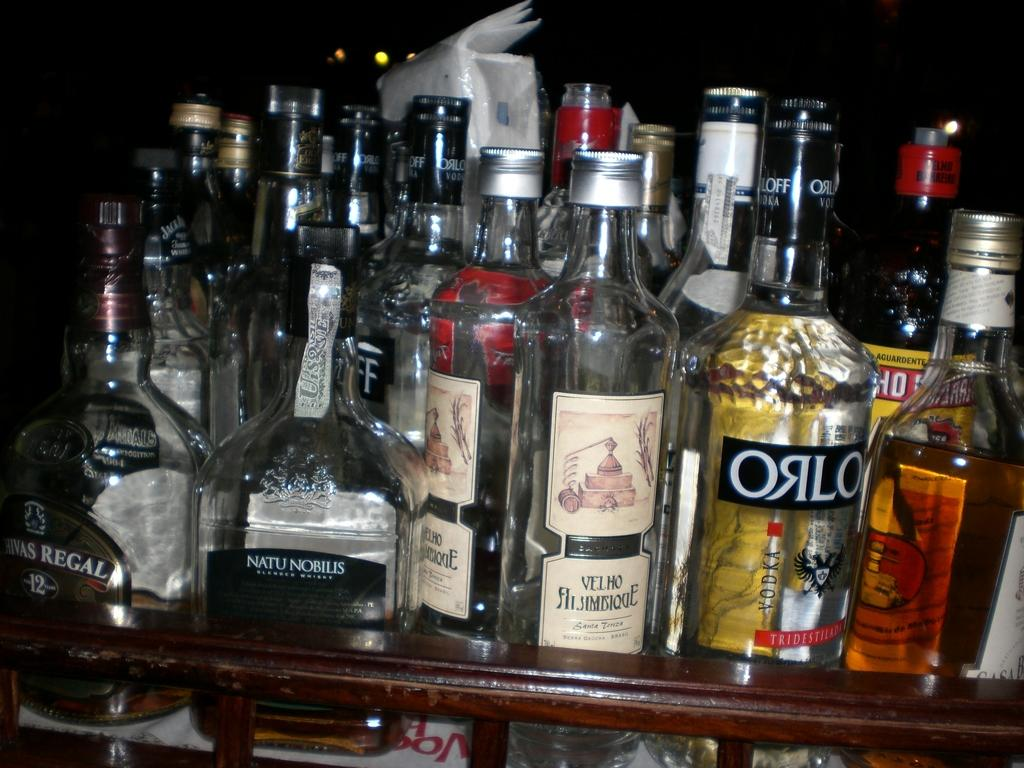<image>
Create a compact narrative representing the image presented. Several empty bottles of varying brands of alcohol are on a shelf with one being ORLO branded towards the front. 